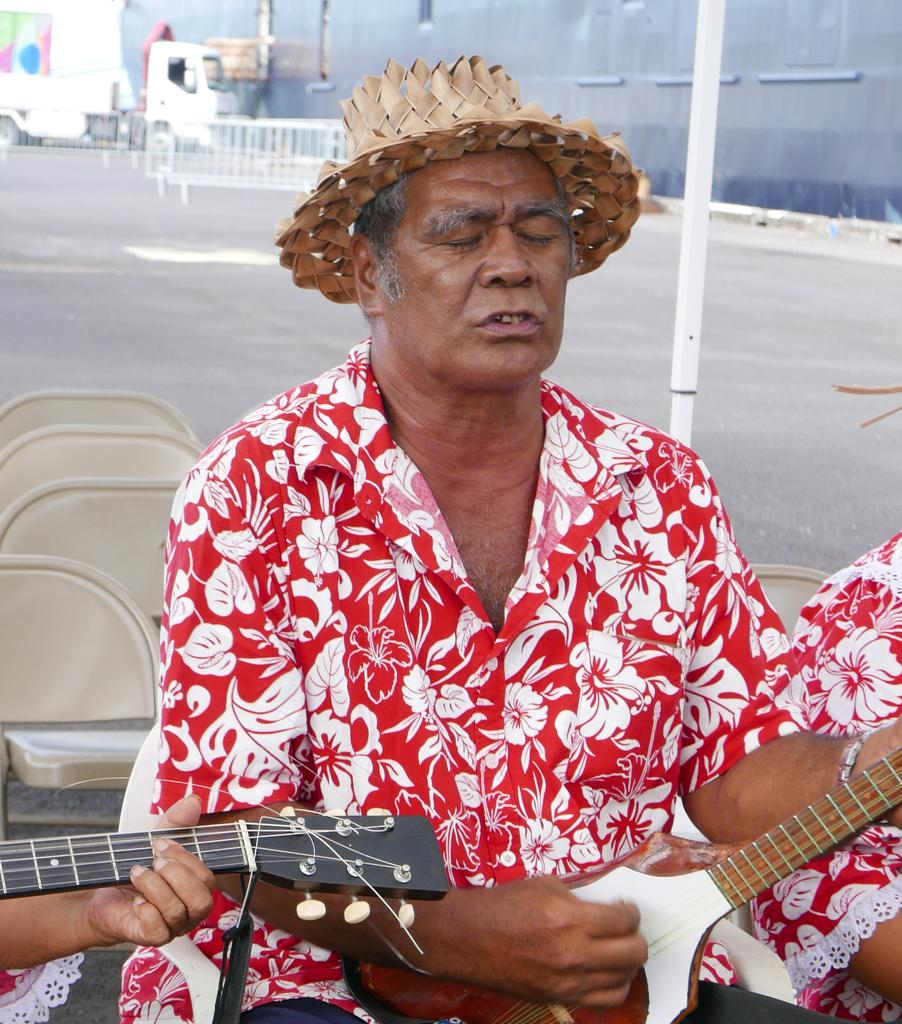What is the man in the image wearing on his upper body? The man is wearing a red shirt. What type of headwear is the man wearing? The man is wearing a hat. What is the man doing in the image? The man is playing a musical instrument. What is the man's seating arrangement in the image? The man is sitting on a chair. What can be seen in the background of the image? There is a road and a truck in the background of the image. What color crayon is the man using to draw on the truck in the image? There is no crayon or drawing activity present in the image. How many days are represented by the week in the image? There is no reference to a week or any time-related concept in the image. 